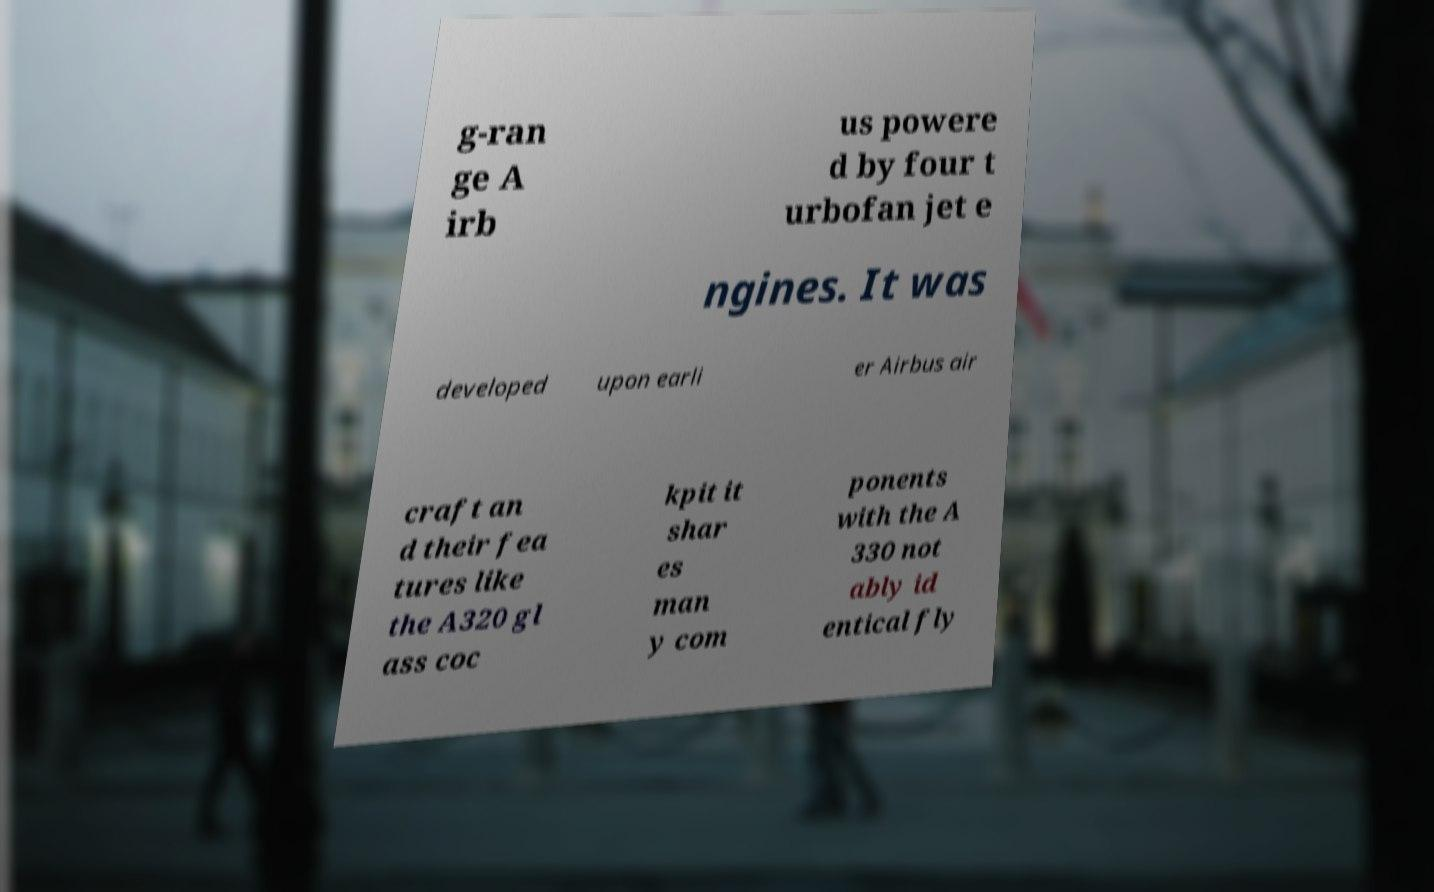What messages or text are displayed in this image? I need them in a readable, typed format. g-ran ge A irb us powere d by four t urbofan jet e ngines. It was developed upon earli er Airbus air craft an d their fea tures like the A320 gl ass coc kpit it shar es man y com ponents with the A 330 not ably id entical fly 